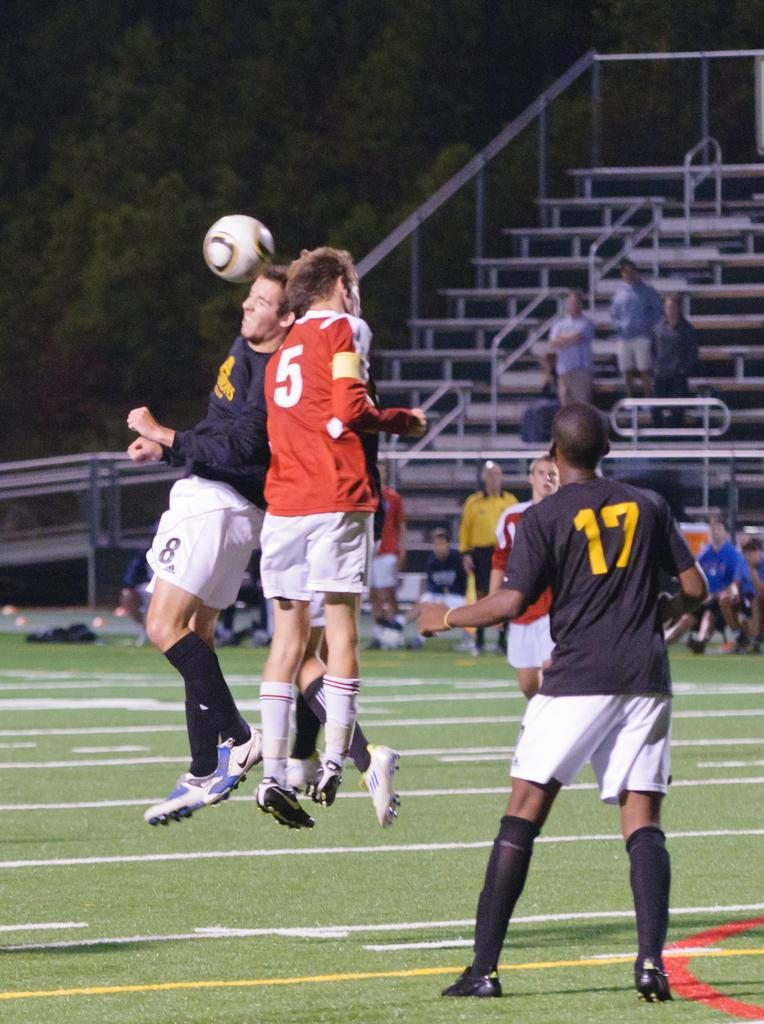<image>
Share a concise interpretation of the image provided. Opposing players number 8 and 5 jump up to give a header to a soccer ball during a game. 